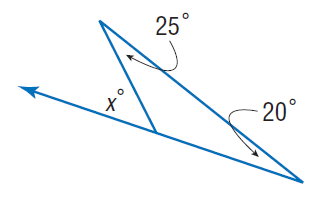Question: Find x.
Choices:
A. 20
B. 25
C. 45
D. 55
Answer with the letter. Answer: C 